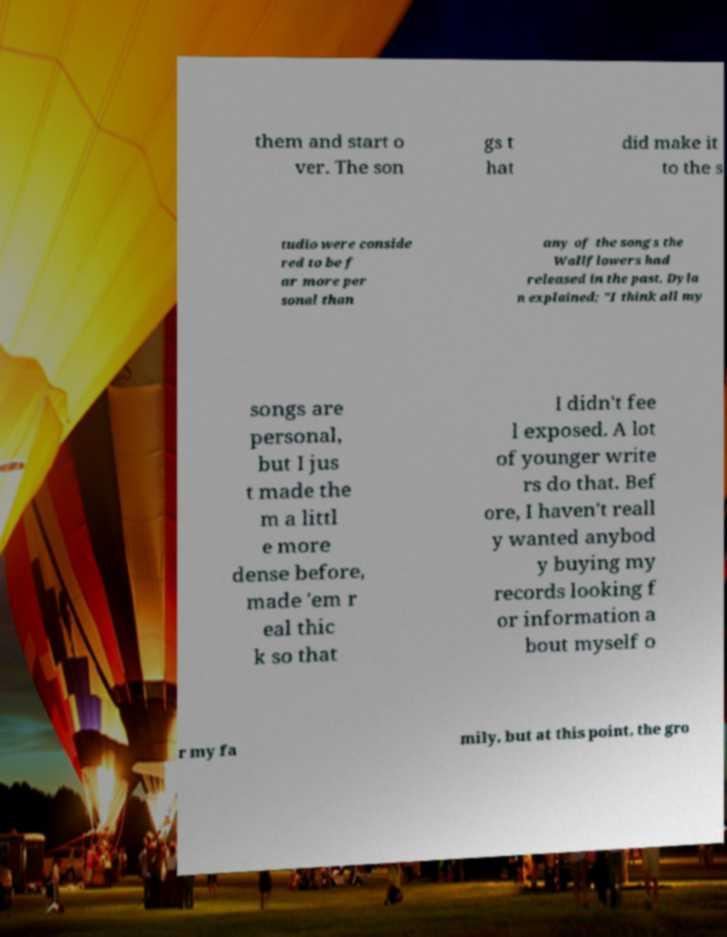Could you assist in decoding the text presented in this image and type it out clearly? them and start o ver. The son gs t hat did make it to the s tudio were conside red to be f ar more per sonal than any of the songs the Wallflowers had released in the past. Dyla n explained; "I think all my songs are personal, but I jus t made the m a littl e more dense before, made 'em r eal thic k so that I didn't fee l exposed. A lot of younger write rs do that. Bef ore, I haven't reall y wanted anybod y buying my records looking f or information a bout myself o r my fa mily, but at this point, the gro 